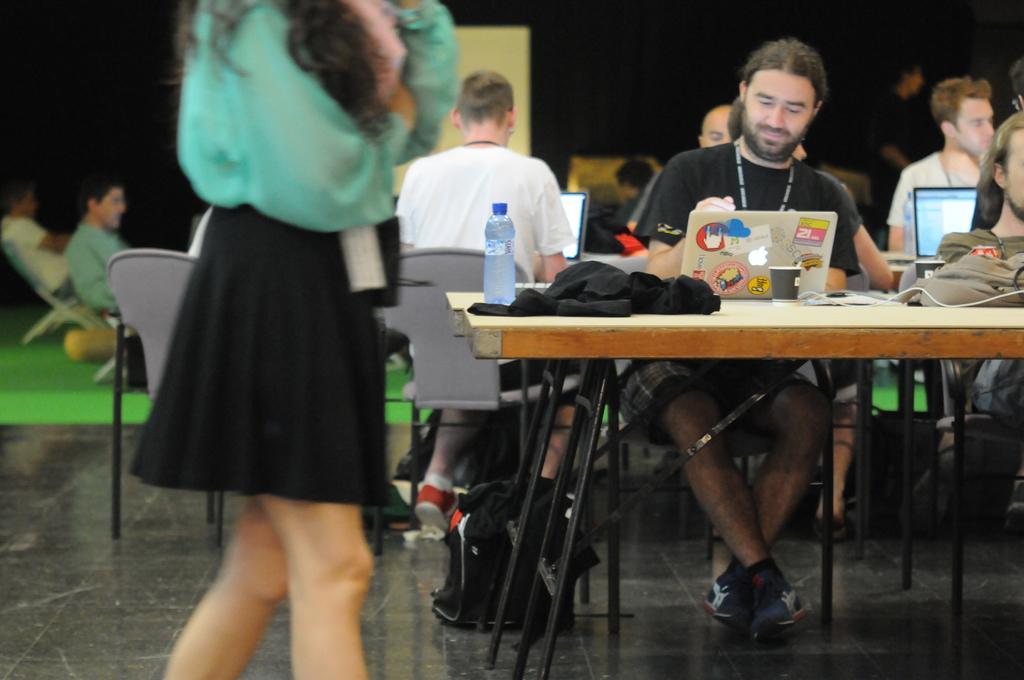In one or two sentences, can you explain what this image depicts? In this image there are group of people. There are laptops, cups, bottle, clothes on the table. At the bottom there is bag and there is a mat. 